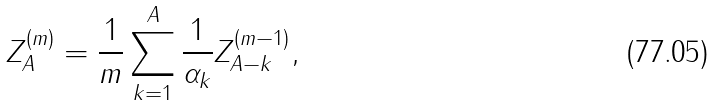<formula> <loc_0><loc_0><loc_500><loc_500>Z _ { A } ^ { ( m ) } = \frac { 1 } { m } \sum _ { k = 1 } ^ { A } \frac { 1 } { \alpha _ { k } } Z _ { A - k } ^ { ( m - 1 ) } ,</formula> 